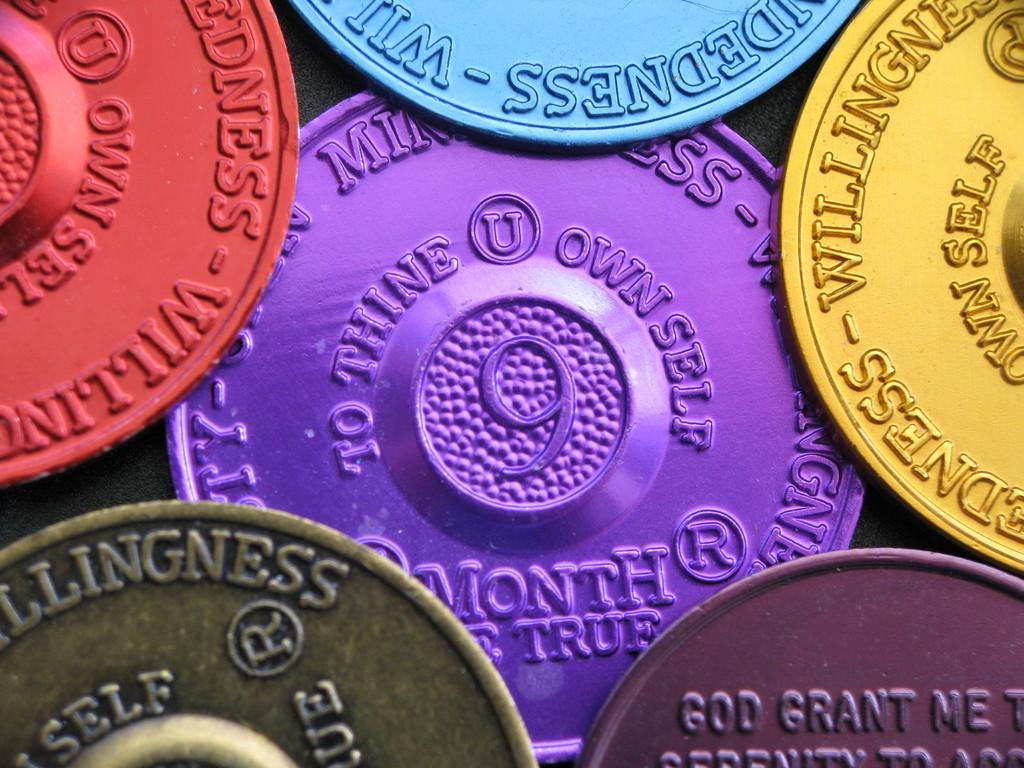<image>
Present a compact description of the photo's key features. Six differently colored coins with the one on the center reading "to thine own self". 